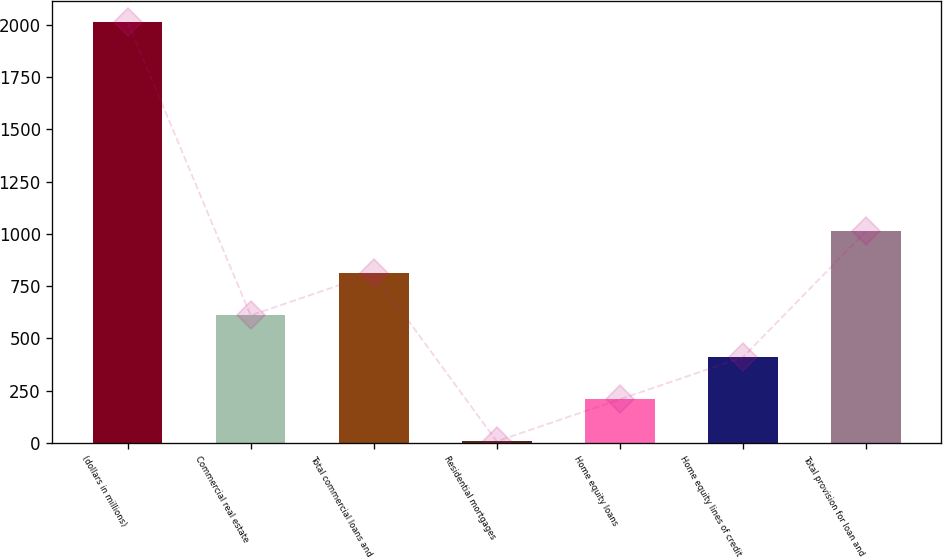Convert chart to OTSL. <chart><loc_0><loc_0><loc_500><loc_500><bar_chart><fcel>(dollars in millions)<fcel>Commercial real estate<fcel>Total commercial loans and<fcel>Residential mortgages<fcel>Home equity loans<fcel>Home equity lines of credit<fcel>Total provision for loan and<nl><fcel>2015<fcel>609.4<fcel>810.2<fcel>7<fcel>207.8<fcel>408.6<fcel>1011<nl></chart> 